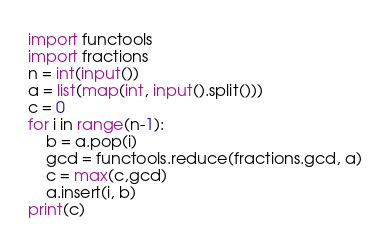Convert code to text. <code><loc_0><loc_0><loc_500><loc_500><_Python_>import functools
import fractions
n = int(input())
a = list(map(int, input().split()))
c = 0
for i in range(n-1):
    b = a.pop(i)
    gcd = functools.reduce(fractions.gcd, a)
    c = max(c,gcd)
    a.insert(i, b)
print(c)</code> 